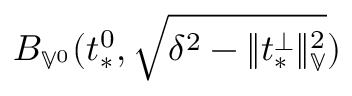<formula> <loc_0><loc_0><loc_500><loc_500>B _ { \mathbb { V } ^ { 0 } } ( t _ { * } ^ { 0 } , \sqrt { \delta ^ { 2 } - \| t _ { * } ^ { \perp } \| _ { \mathbb { V } } ^ { 2 } } )</formula> 